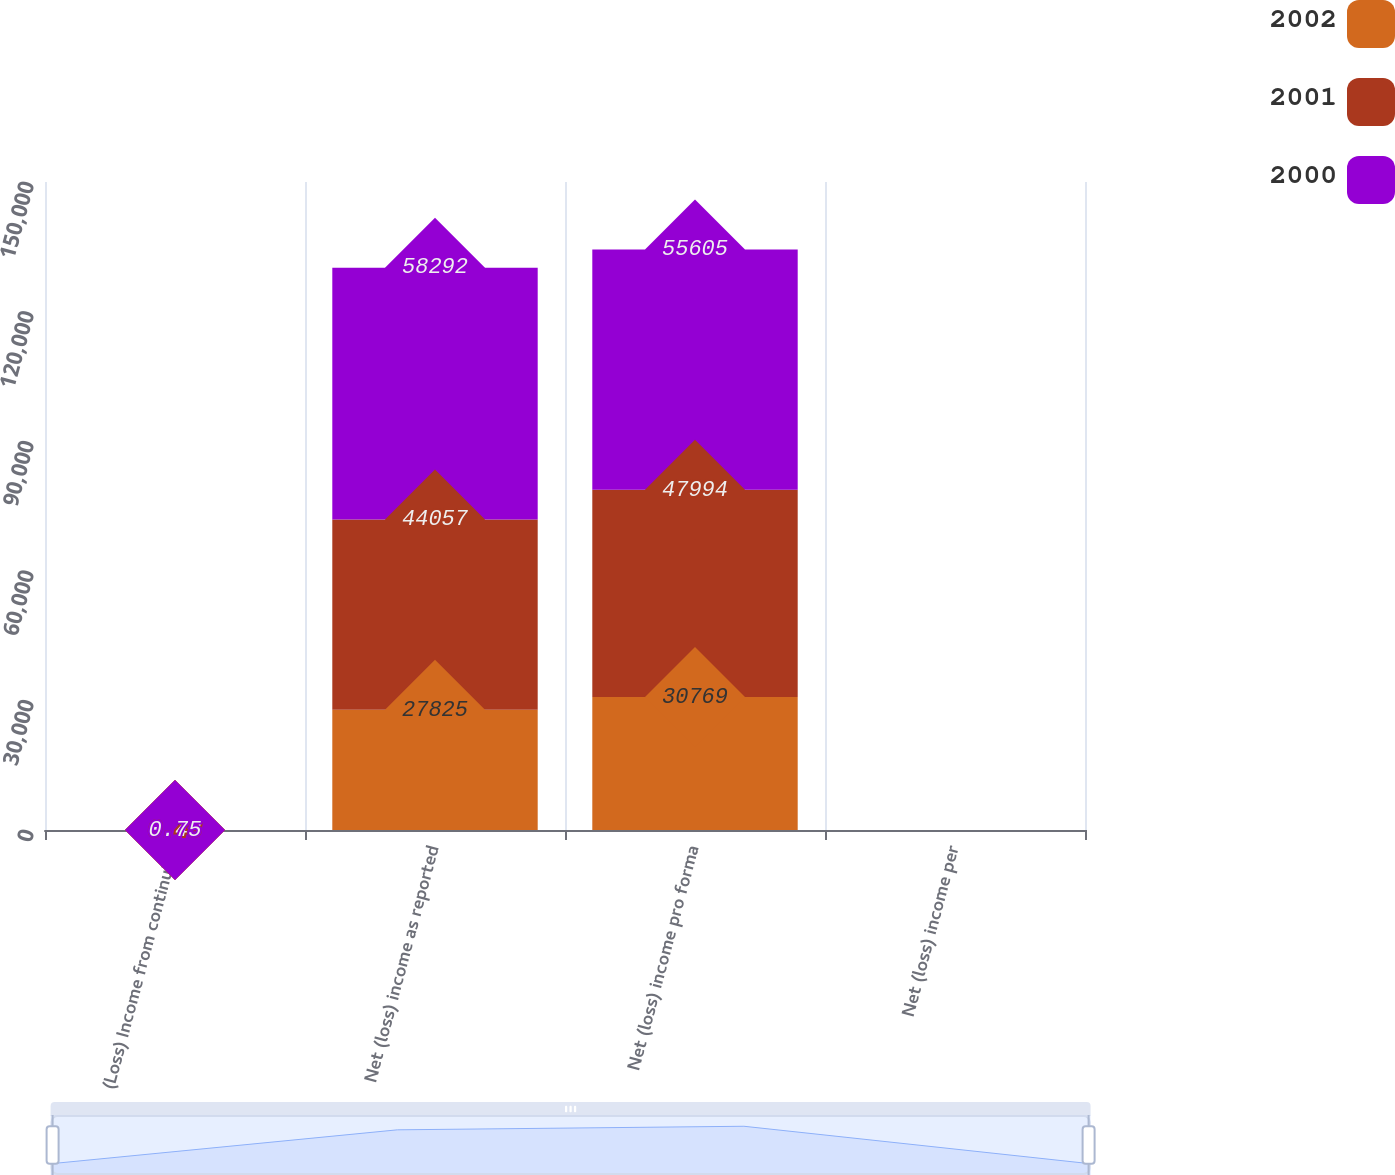<chart> <loc_0><loc_0><loc_500><loc_500><stacked_bar_chart><ecel><fcel>(Loss) Income from continuing<fcel>Net (loss) income as reported<fcel>Net (loss) income pro forma<fcel>Net (loss) income per<nl><fcel>2002<fcel>0.35<fcel>27825<fcel>30769<fcel>0.39<nl><fcel>2001<fcel>0.43<fcel>44057<fcel>47994<fcel>0.57<nl><fcel>2000<fcel>0.75<fcel>58292<fcel>55605<fcel>0.65<nl></chart> 